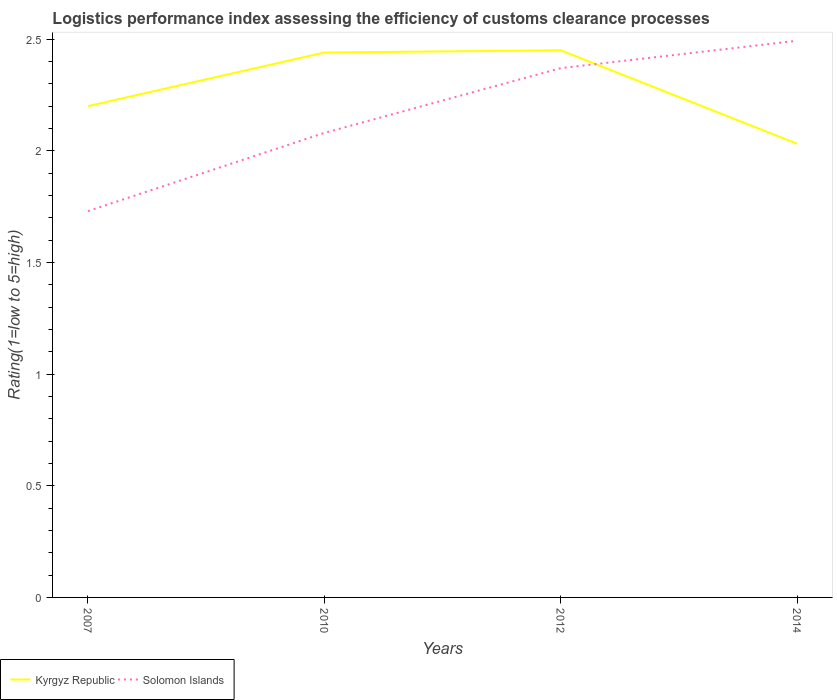Across all years, what is the maximum Logistic performance index in Kyrgyz Republic?
Your answer should be very brief. 2.03. What is the total Logistic performance index in Kyrgyz Republic in the graph?
Your answer should be very brief. -0.24. What is the difference between the highest and the second highest Logistic performance index in Solomon Islands?
Your response must be concise. 0.76. What is the difference between the highest and the lowest Logistic performance index in Solomon Islands?
Provide a short and direct response. 2. How many lines are there?
Give a very brief answer. 2. What is the difference between two consecutive major ticks on the Y-axis?
Make the answer very short. 0.5. Does the graph contain grids?
Ensure brevity in your answer.  No. Where does the legend appear in the graph?
Offer a terse response. Bottom left. How many legend labels are there?
Provide a succinct answer. 2. What is the title of the graph?
Ensure brevity in your answer.  Logistics performance index assessing the efficiency of customs clearance processes. Does "Estonia" appear as one of the legend labels in the graph?
Make the answer very short. No. What is the label or title of the Y-axis?
Offer a terse response. Rating(1=low to 5=high). What is the Rating(1=low to 5=high) in Kyrgyz Republic in 2007?
Provide a short and direct response. 2.2. What is the Rating(1=low to 5=high) in Solomon Islands in 2007?
Ensure brevity in your answer.  1.73. What is the Rating(1=low to 5=high) in Kyrgyz Republic in 2010?
Your answer should be compact. 2.44. What is the Rating(1=low to 5=high) of Solomon Islands in 2010?
Provide a succinct answer. 2.08. What is the Rating(1=low to 5=high) in Kyrgyz Republic in 2012?
Offer a terse response. 2.45. What is the Rating(1=low to 5=high) of Solomon Islands in 2012?
Ensure brevity in your answer.  2.37. What is the Rating(1=low to 5=high) of Kyrgyz Republic in 2014?
Give a very brief answer. 2.03. What is the Rating(1=low to 5=high) in Solomon Islands in 2014?
Make the answer very short. 2.49. Across all years, what is the maximum Rating(1=low to 5=high) in Kyrgyz Republic?
Ensure brevity in your answer.  2.45. Across all years, what is the maximum Rating(1=low to 5=high) in Solomon Islands?
Keep it short and to the point. 2.49. Across all years, what is the minimum Rating(1=low to 5=high) of Kyrgyz Republic?
Provide a succinct answer. 2.03. Across all years, what is the minimum Rating(1=low to 5=high) of Solomon Islands?
Give a very brief answer. 1.73. What is the total Rating(1=low to 5=high) of Kyrgyz Republic in the graph?
Your answer should be very brief. 9.12. What is the total Rating(1=low to 5=high) in Solomon Islands in the graph?
Ensure brevity in your answer.  8.67. What is the difference between the Rating(1=low to 5=high) of Kyrgyz Republic in 2007 and that in 2010?
Offer a very short reply. -0.24. What is the difference between the Rating(1=low to 5=high) in Solomon Islands in 2007 and that in 2010?
Offer a very short reply. -0.35. What is the difference between the Rating(1=low to 5=high) in Solomon Islands in 2007 and that in 2012?
Offer a terse response. -0.64. What is the difference between the Rating(1=low to 5=high) in Kyrgyz Republic in 2007 and that in 2014?
Make the answer very short. 0.17. What is the difference between the Rating(1=low to 5=high) of Solomon Islands in 2007 and that in 2014?
Give a very brief answer. -0.76. What is the difference between the Rating(1=low to 5=high) in Kyrgyz Republic in 2010 and that in 2012?
Offer a terse response. -0.01. What is the difference between the Rating(1=low to 5=high) of Solomon Islands in 2010 and that in 2012?
Provide a succinct answer. -0.29. What is the difference between the Rating(1=low to 5=high) in Kyrgyz Republic in 2010 and that in 2014?
Keep it short and to the point. 0.41. What is the difference between the Rating(1=low to 5=high) in Solomon Islands in 2010 and that in 2014?
Provide a short and direct response. -0.41. What is the difference between the Rating(1=low to 5=high) of Kyrgyz Republic in 2012 and that in 2014?
Your answer should be very brief. 0.42. What is the difference between the Rating(1=low to 5=high) of Solomon Islands in 2012 and that in 2014?
Give a very brief answer. -0.12. What is the difference between the Rating(1=low to 5=high) of Kyrgyz Republic in 2007 and the Rating(1=low to 5=high) of Solomon Islands in 2010?
Offer a terse response. 0.12. What is the difference between the Rating(1=low to 5=high) of Kyrgyz Republic in 2007 and the Rating(1=low to 5=high) of Solomon Islands in 2012?
Your answer should be very brief. -0.17. What is the difference between the Rating(1=low to 5=high) in Kyrgyz Republic in 2007 and the Rating(1=low to 5=high) in Solomon Islands in 2014?
Offer a terse response. -0.29. What is the difference between the Rating(1=low to 5=high) of Kyrgyz Republic in 2010 and the Rating(1=low to 5=high) of Solomon Islands in 2012?
Offer a terse response. 0.07. What is the difference between the Rating(1=low to 5=high) in Kyrgyz Republic in 2010 and the Rating(1=low to 5=high) in Solomon Islands in 2014?
Make the answer very short. -0.05. What is the difference between the Rating(1=low to 5=high) in Kyrgyz Republic in 2012 and the Rating(1=low to 5=high) in Solomon Islands in 2014?
Your answer should be compact. -0.04. What is the average Rating(1=low to 5=high) of Kyrgyz Republic per year?
Offer a very short reply. 2.28. What is the average Rating(1=low to 5=high) of Solomon Islands per year?
Offer a terse response. 2.17. In the year 2007, what is the difference between the Rating(1=low to 5=high) in Kyrgyz Republic and Rating(1=low to 5=high) in Solomon Islands?
Offer a very short reply. 0.47. In the year 2010, what is the difference between the Rating(1=low to 5=high) of Kyrgyz Republic and Rating(1=low to 5=high) of Solomon Islands?
Offer a terse response. 0.36. In the year 2014, what is the difference between the Rating(1=low to 5=high) of Kyrgyz Republic and Rating(1=low to 5=high) of Solomon Islands?
Your answer should be compact. -0.46. What is the ratio of the Rating(1=low to 5=high) of Kyrgyz Republic in 2007 to that in 2010?
Offer a very short reply. 0.9. What is the ratio of the Rating(1=low to 5=high) in Solomon Islands in 2007 to that in 2010?
Make the answer very short. 0.83. What is the ratio of the Rating(1=low to 5=high) of Kyrgyz Republic in 2007 to that in 2012?
Keep it short and to the point. 0.9. What is the ratio of the Rating(1=low to 5=high) in Solomon Islands in 2007 to that in 2012?
Keep it short and to the point. 0.73. What is the ratio of the Rating(1=low to 5=high) in Kyrgyz Republic in 2007 to that in 2014?
Give a very brief answer. 1.08. What is the ratio of the Rating(1=low to 5=high) of Solomon Islands in 2007 to that in 2014?
Your answer should be compact. 0.69. What is the ratio of the Rating(1=low to 5=high) in Solomon Islands in 2010 to that in 2012?
Offer a terse response. 0.88. What is the ratio of the Rating(1=low to 5=high) of Kyrgyz Republic in 2010 to that in 2014?
Offer a very short reply. 1.2. What is the ratio of the Rating(1=low to 5=high) of Solomon Islands in 2010 to that in 2014?
Your answer should be compact. 0.83. What is the ratio of the Rating(1=low to 5=high) of Kyrgyz Republic in 2012 to that in 2014?
Provide a succinct answer. 1.21. What is the ratio of the Rating(1=low to 5=high) in Solomon Islands in 2012 to that in 2014?
Offer a very short reply. 0.95. What is the difference between the highest and the second highest Rating(1=low to 5=high) in Solomon Islands?
Make the answer very short. 0.12. What is the difference between the highest and the lowest Rating(1=low to 5=high) in Kyrgyz Republic?
Your answer should be compact. 0.42. What is the difference between the highest and the lowest Rating(1=low to 5=high) in Solomon Islands?
Keep it short and to the point. 0.76. 